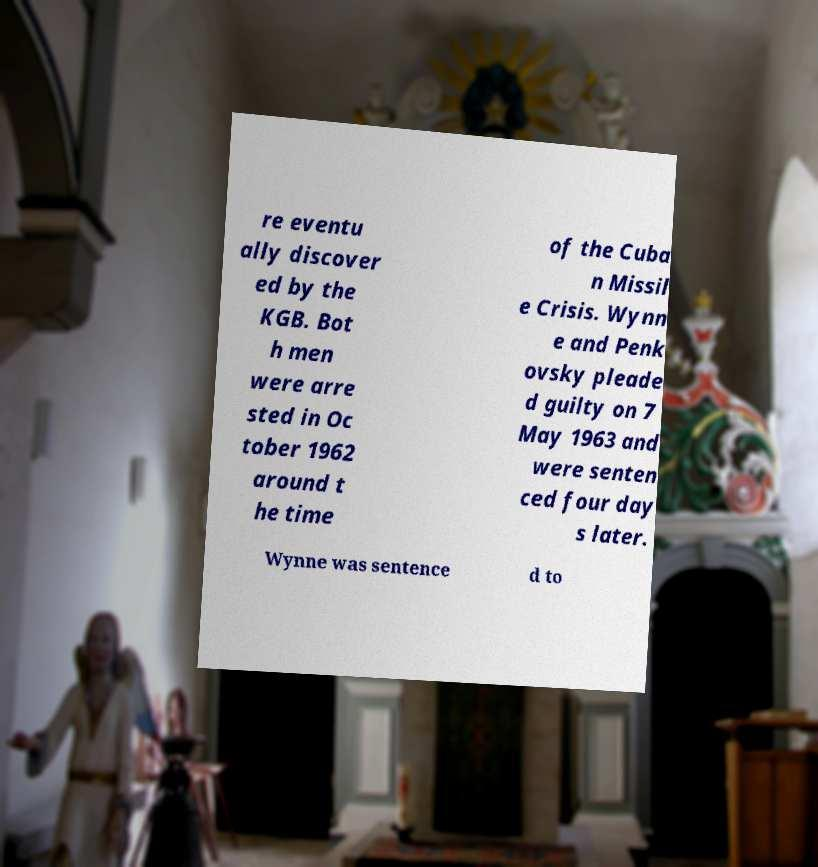Could you assist in decoding the text presented in this image and type it out clearly? re eventu ally discover ed by the KGB. Bot h men were arre sted in Oc tober 1962 around t he time of the Cuba n Missil e Crisis. Wynn e and Penk ovsky pleade d guilty on 7 May 1963 and were senten ced four day s later. Wynne was sentence d to 